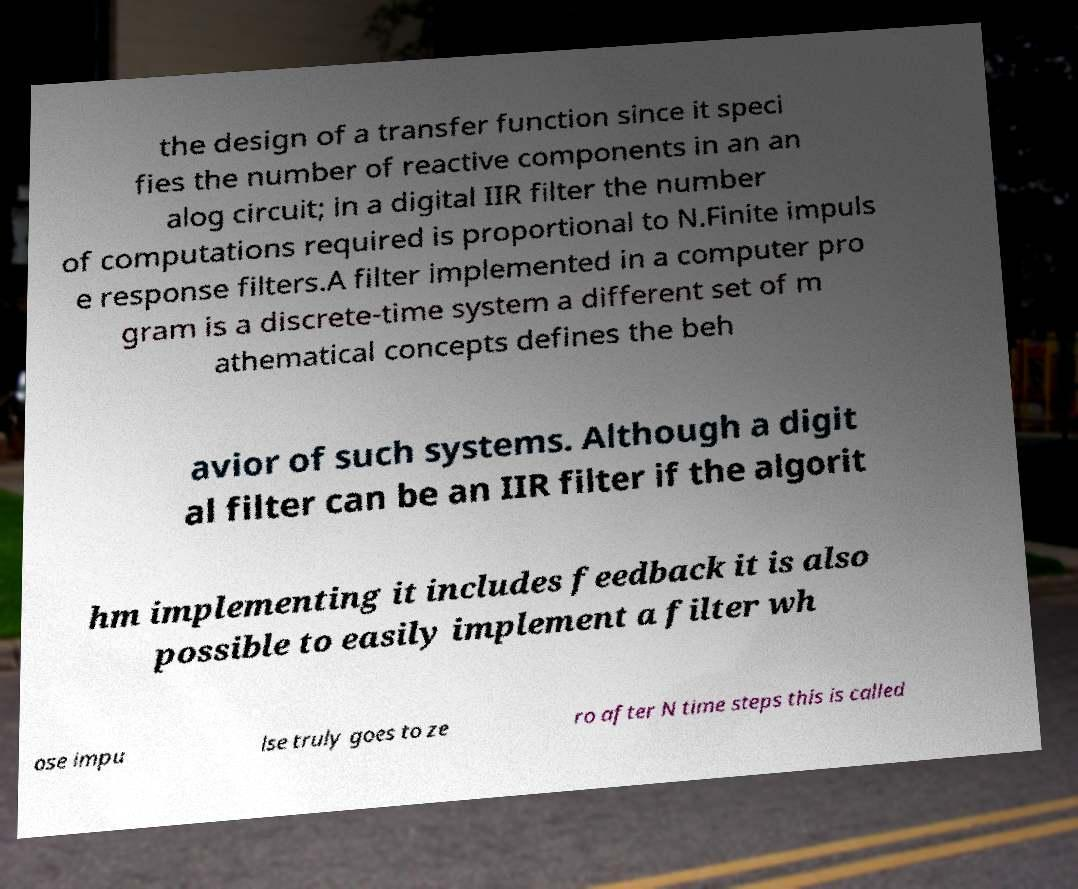There's text embedded in this image that I need extracted. Can you transcribe it verbatim? the design of a transfer function since it speci fies the number of reactive components in an an alog circuit; in a digital IIR filter the number of computations required is proportional to N.Finite impuls e response filters.A filter implemented in a computer pro gram is a discrete-time system a different set of m athematical concepts defines the beh avior of such systems. Although a digit al filter can be an IIR filter if the algorit hm implementing it includes feedback it is also possible to easily implement a filter wh ose impu lse truly goes to ze ro after N time steps this is called 